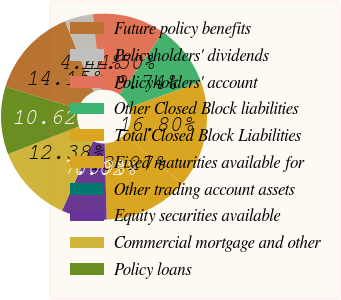Convert chart. <chart><loc_0><loc_0><loc_500><loc_500><pie_chart><fcel>Future policy benefits<fcel>Policyholders' dividends<fcel>Policyholders' account<fcel>Other Closed Block liabilities<fcel>Total Closed Block Liabilities<fcel>Fixed maturities available for<fcel>Other trading account assets<fcel>Equity securities available<fcel>Commercial mortgage and other<fcel>Policy loans<nl><fcel>14.15%<fcel>4.44%<fcel>11.5%<fcel>9.74%<fcel>16.8%<fcel>13.27%<fcel>0.02%<fcel>7.09%<fcel>12.38%<fcel>10.62%<nl></chart> 